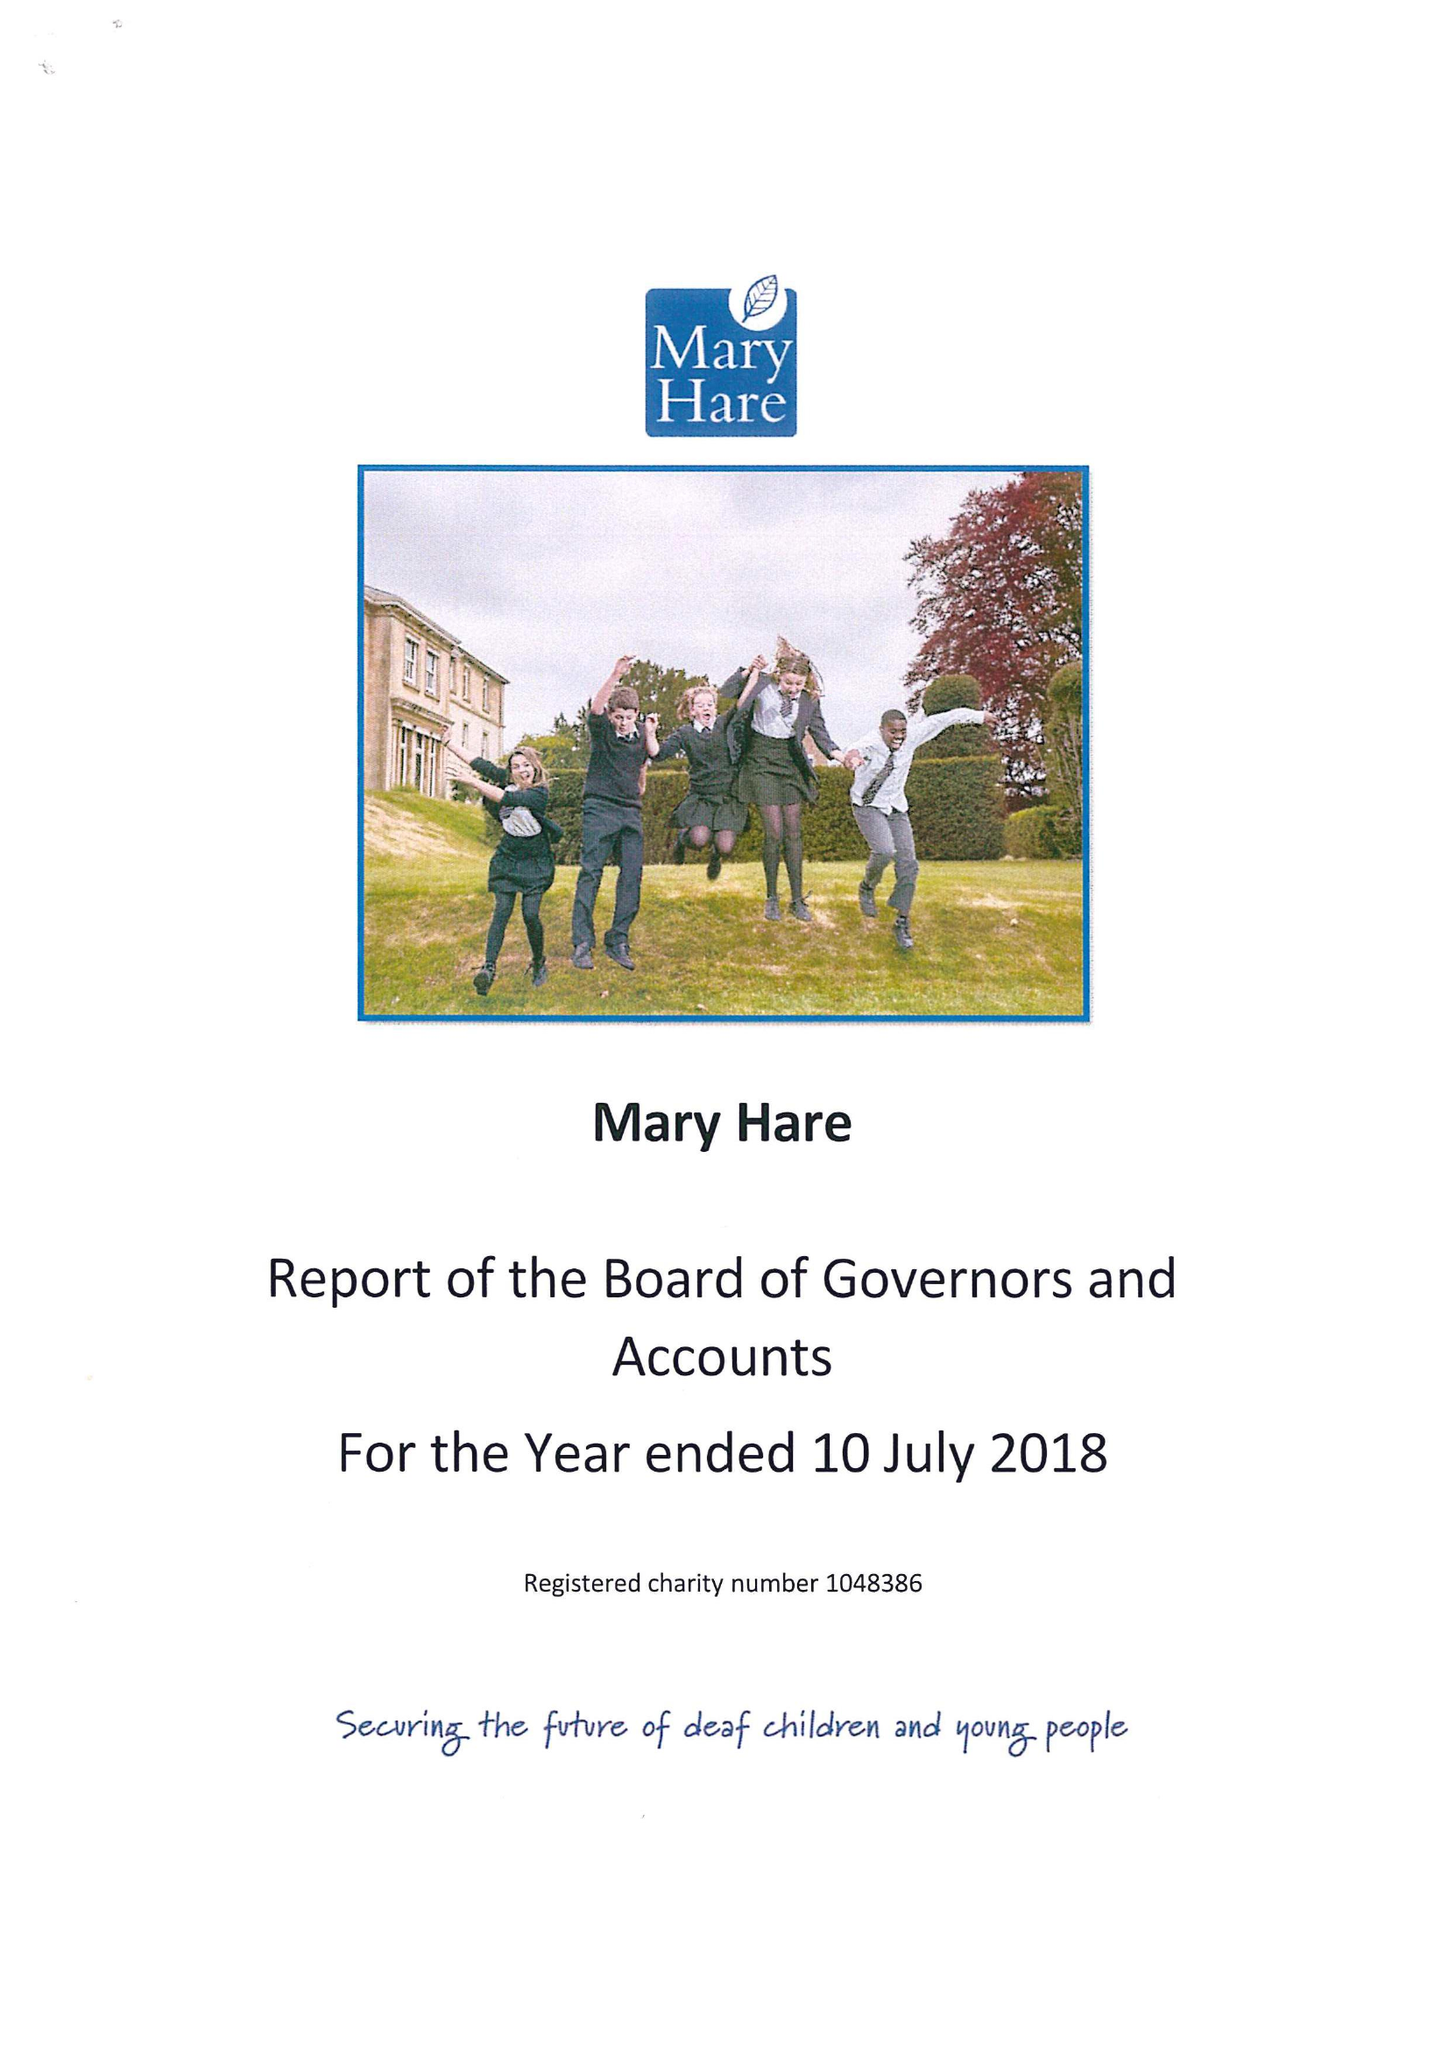What is the value for the income_annually_in_british_pounds?
Answer the question using a single word or phrase. 12609000.00 